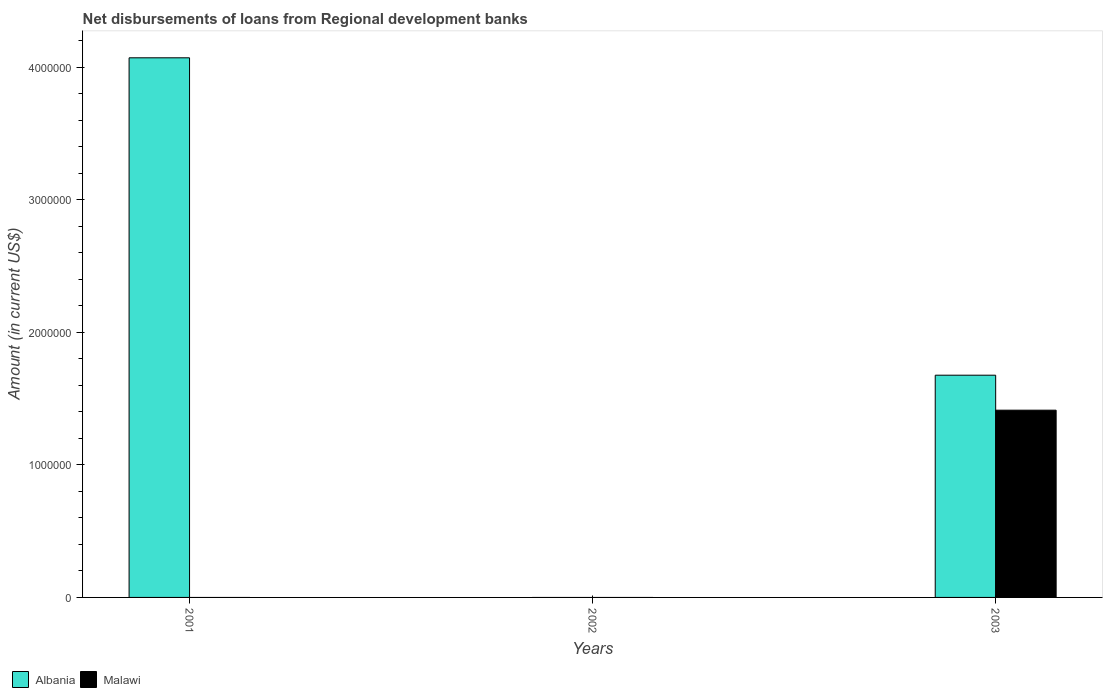Are the number of bars per tick equal to the number of legend labels?
Your response must be concise. No. Are the number of bars on each tick of the X-axis equal?
Your answer should be compact. No. How many bars are there on the 3rd tick from the left?
Provide a short and direct response. 2. What is the label of the 2nd group of bars from the left?
Give a very brief answer. 2002. What is the amount of disbursements of loans from regional development banks in Malawi in 2001?
Keep it short and to the point. 0. Across all years, what is the maximum amount of disbursements of loans from regional development banks in Albania?
Provide a short and direct response. 4.07e+06. Across all years, what is the minimum amount of disbursements of loans from regional development banks in Albania?
Provide a succinct answer. 0. What is the total amount of disbursements of loans from regional development banks in Malawi in the graph?
Make the answer very short. 1.41e+06. What is the difference between the amount of disbursements of loans from regional development banks in Albania in 2001 and that in 2003?
Make the answer very short. 2.40e+06. What is the difference between the amount of disbursements of loans from regional development banks in Malawi in 2003 and the amount of disbursements of loans from regional development banks in Albania in 2001?
Your answer should be very brief. -2.66e+06. What is the average amount of disbursements of loans from regional development banks in Albania per year?
Offer a very short reply. 1.92e+06. In the year 2003, what is the difference between the amount of disbursements of loans from regional development banks in Albania and amount of disbursements of loans from regional development banks in Malawi?
Give a very brief answer. 2.64e+05. What is the ratio of the amount of disbursements of loans from regional development banks in Albania in 2001 to that in 2003?
Your answer should be very brief. 2.43. Is the amount of disbursements of loans from regional development banks in Albania in 2001 less than that in 2003?
Give a very brief answer. No. What is the difference between the highest and the lowest amount of disbursements of loans from regional development banks in Malawi?
Give a very brief answer. 1.41e+06. How many bars are there?
Ensure brevity in your answer.  3. What is the difference between two consecutive major ticks on the Y-axis?
Keep it short and to the point. 1.00e+06. Are the values on the major ticks of Y-axis written in scientific E-notation?
Provide a short and direct response. No. Does the graph contain grids?
Your answer should be very brief. No. How many legend labels are there?
Offer a terse response. 2. What is the title of the graph?
Make the answer very short. Net disbursements of loans from Regional development banks. What is the label or title of the X-axis?
Provide a succinct answer. Years. What is the Amount (in current US$) of Albania in 2001?
Provide a succinct answer. 4.07e+06. What is the Amount (in current US$) of Albania in 2002?
Provide a short and direct response. 0. What is the Amount (in current US$) of Malawi in 2002?
Your response must be concise. 0. What is the Amount (in current US$) of Albania in 2003?
Keep it short and to the point. 1.68e+06. What is the Amount (in current US$) of Malawi in 2003?
Offer a terse response. 1.41e+06. Across all years, what is the maximum Amount (in current US$) of Albania?
Ensure brevity in your answer.  4.07e+06. Across all years, what is the maximum Amount (in current US$) in Malawi?
Your answer should be very brief. 1.41e+06. Across all years, what is the minimum Amount (in current US$) in Albania?
Offer a terse response. 0. Across all years, what is the minimum Amount (in current US$) in Malawi?
Your answer should be very brief. 0. What is the total Amount (in current US$) of Albania in the graph?
Your answer should be compact. 5.75e+06. What is the total Amount (in current US$) in Malawi in the graph?
Your response must be concise. 1.41e+06. What is the difference between the Amount (in current US$) in Albania in 2001 and that in 2003?
Provide a short and direct response. 2.40e+06. What is the difference between the Amount (in current US$) of Albania in 2001 and the Amount (in current US$) of Malawi in 2003?
Your answer should be compact. 2.66e+06. What is the average Amount (in current US$) in Albania per year?
Your answer should be very brief. 1.92e+06. What is the average Amount (in current US$) of Malawi per year?
Ensure brevity in your answer.  4.71e+05. In the year 2003, what is the difference between the Amount (in current US$) in Albania and Amount (in current US$) in Malawi?
Make the answer very short. 2.64e+05. What is the ratio of the Amount (in current US$) of Albania in 2001 to that in 2003?
Give a very brief answer. 2.43. What is the difference between the highest and the lowest Amount (in current US$) of Albania?
Your answer should be compact. 4.07e+06. What is the difference between the highest and the lowest Amount (in current US$) in Malawi?
Make the answer very short. 1.41e+06. 